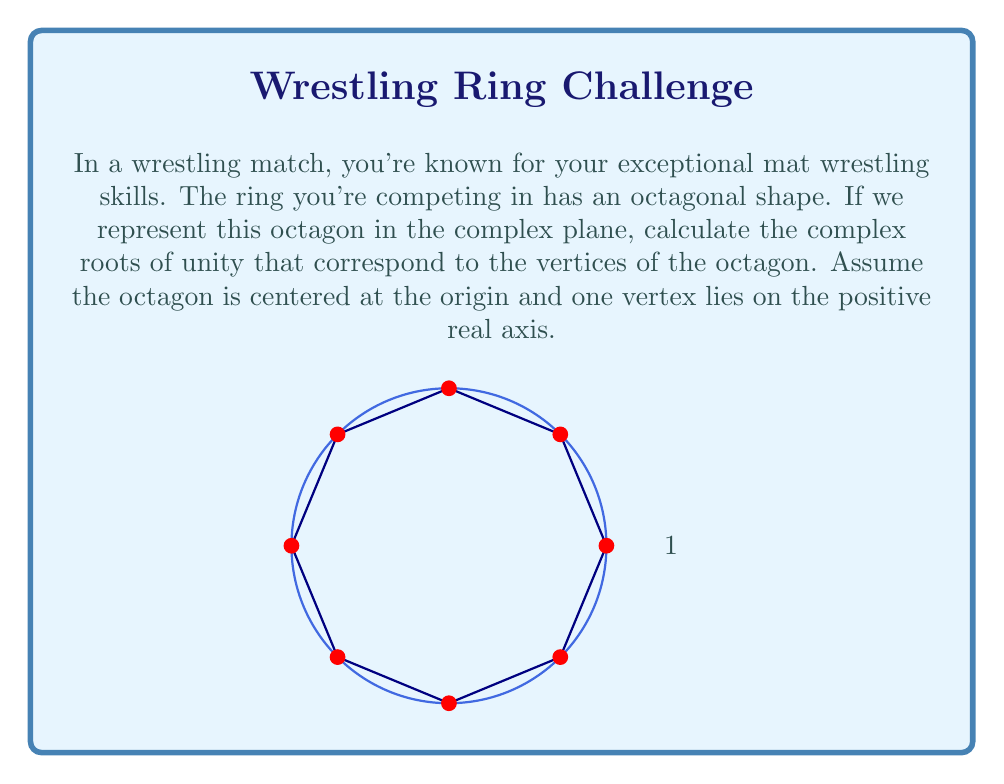Solve this math problem. Let's approach this step-by-step:

1) The complex roots of unity for an n-sided regular polygon are given by the formula:

   $$z_k = e^{2\pi i k / n}$$

   where $k = 0, 1, 2, ..., n-1$

2) In this case, we have an octagon, so $n = 8$

3) Substituting this into our formula:

   $$z_k = e^{2\pi i k / 8} = e^{\pi i k / 4}$$

4) Now, let's calculate each root for $k = 0, 1, 2, ..., 7$:

   For $k = 0$: $z_0 = e^{0} = 1$
   For $k = 1$: $z_1 = e^{\pi i / 4} = \frac{1}{\sqrt{2}} + \frac{i}{\sqrt{2}}$
   For $k = 2$: $z_2 = e^{\pi i / 2} = i$
   For $k = 3$: $z_3 = e^{3\pi i / 4} = -\frac{1}{\sqrt{2}} + \frac{i}{\sqrt{2}}$
   For $k = 4$: $z_4 = e^{\pi i} = -1$
   For $k = 5$: $z_5 = e^{5\pi i / 4} = -\frac{1}{\sqrt{2}} - \frac{i}{\sqrt{2}}$
   For $k = 6$: $z_6 = e^{3\pi i / 2} = -i$
   For $k = 7$: $z_7 = e^{7\pi i / 4} = \frac{1}{\sqrt{2}} - \frac{i}{\sqrt{2}}$

5) These complex numbers represent the vertices of the octagonal ring in the complex plane, starting from the positive real axis and moving counterclockwise.
Answer: $1, \frac{1}{\sqrt{2}}(1+i), i, \frac{1}{\sqrt{2}}(-1+i), -1, \frac{1}{\sqrt{2}}(-1-i), -i, \frac{1}{\sqrt{2}}(1-i)$ 